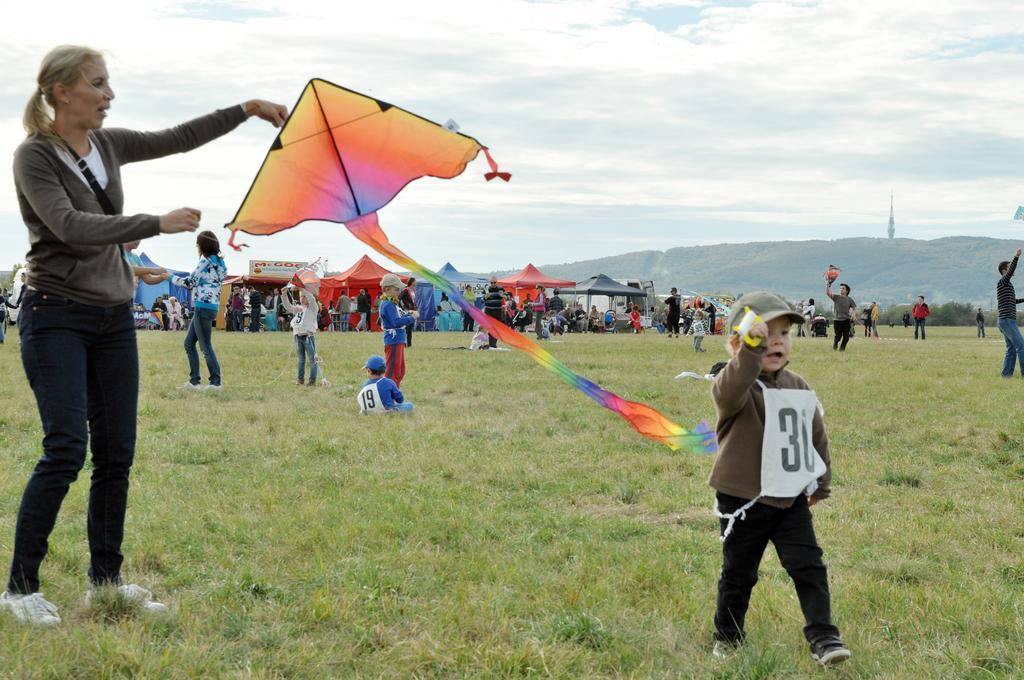How would you summarize this image in a sentence or two? In the foreground I can see a crowd on grass, kites, umbrella huts and stalls. In the background I can see trees, mountains, tower, houses and the sky. This image is taken may be during a day. 